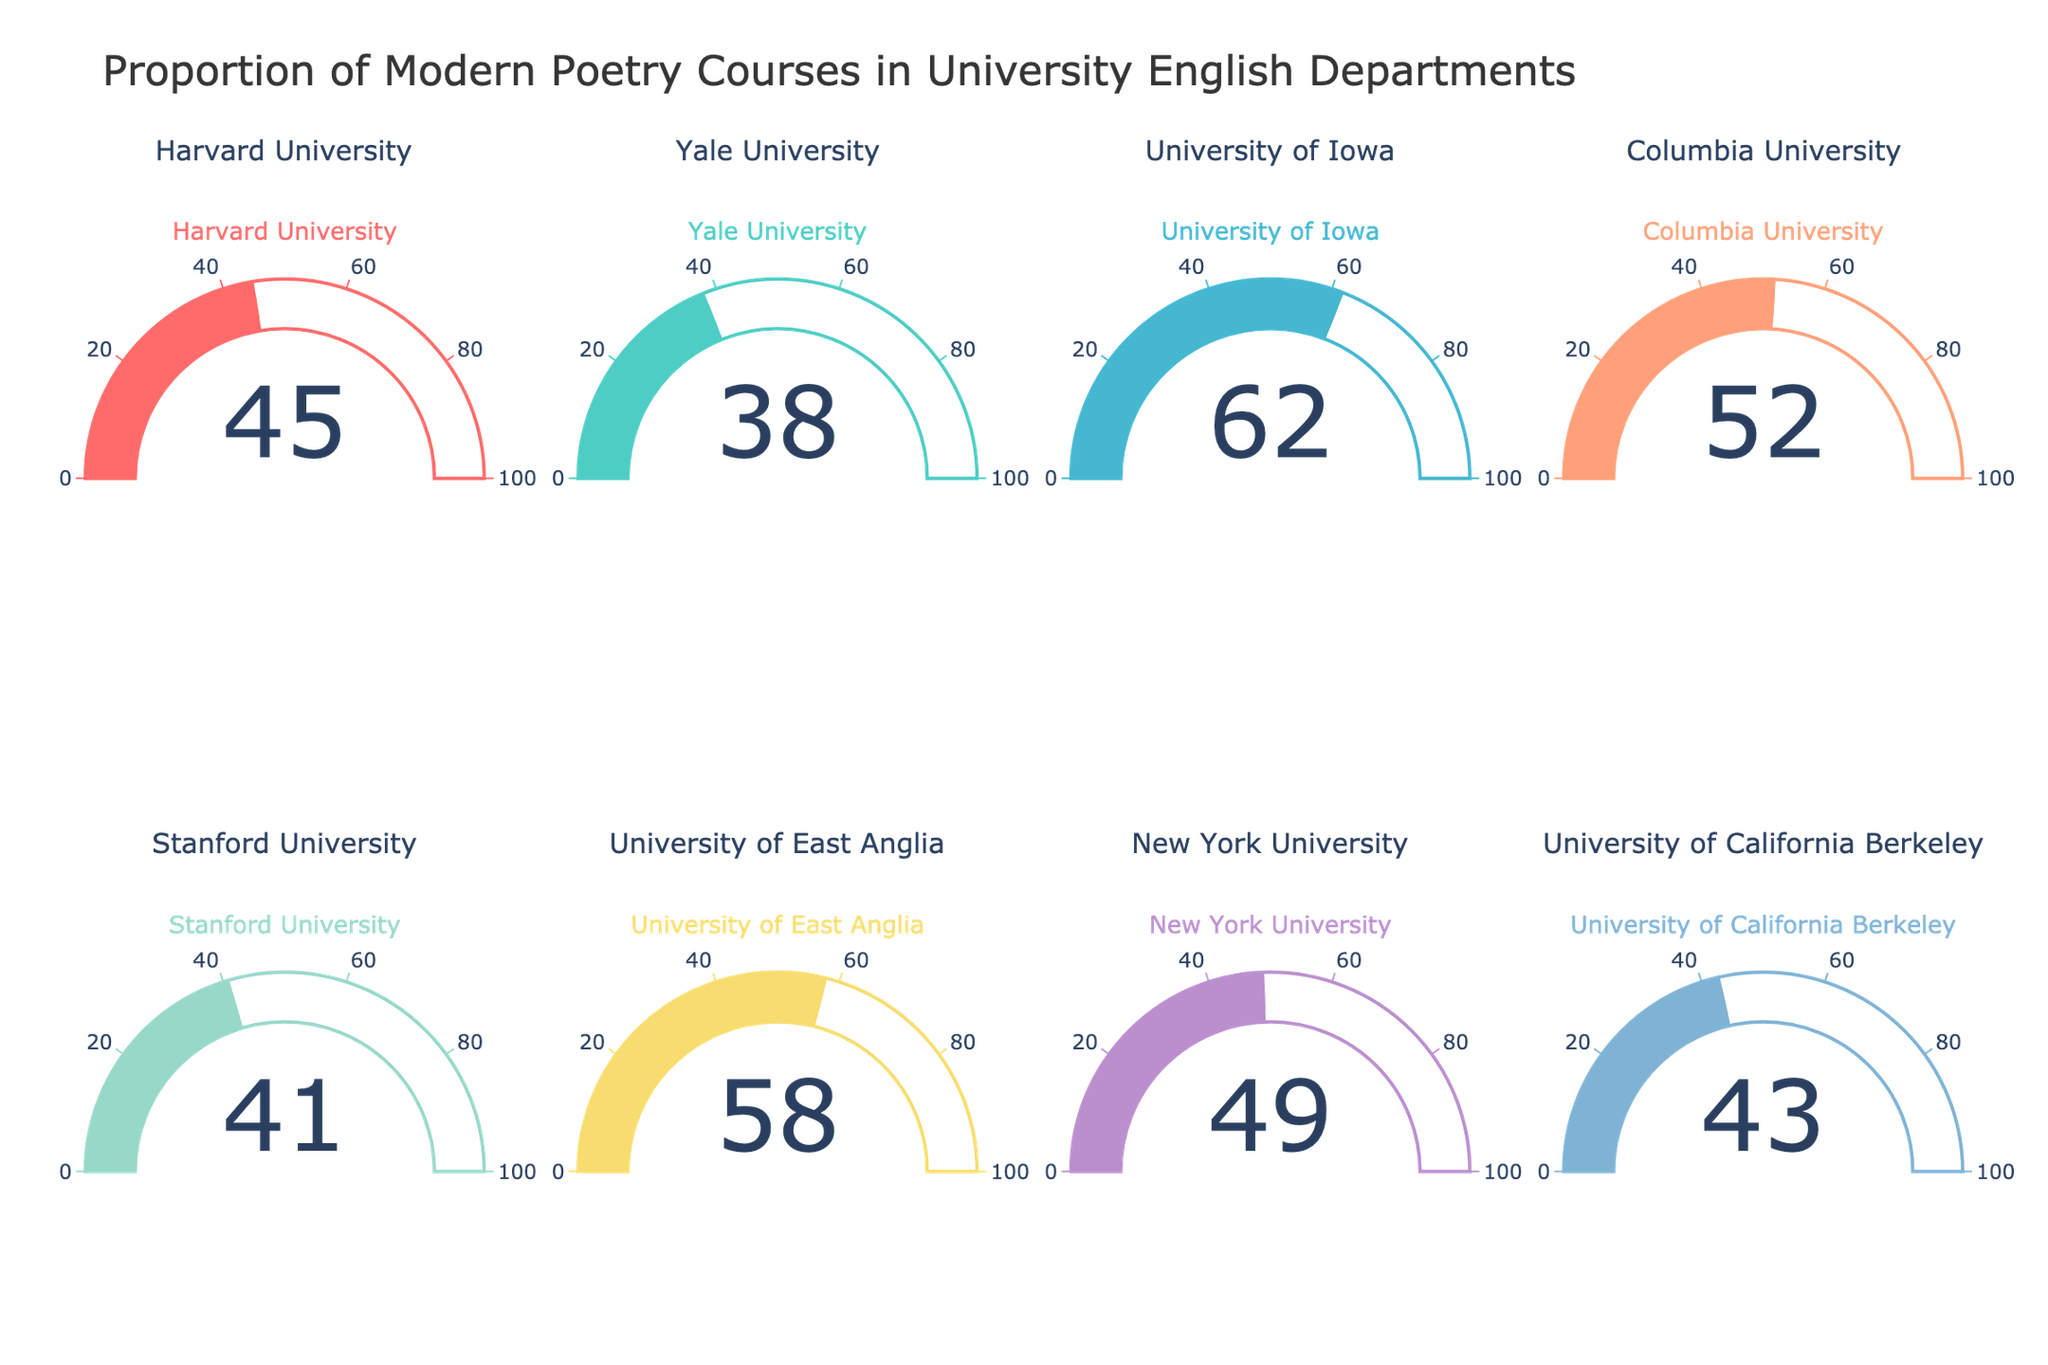what is the highest percentage of modern poetry courses offered? By examining the gauge charts, find the maximum value shown.
Answer: 62% Which university offers the lowest percentage of modern poetry courses? Look at all the gauge charts and identify the university with the smallest number.
Answer: Yale University What's the average percentage of modern poetry courses across all universities? Sum the percentages and divide by the number of universities: (45+38+62+52+41+58+49+43) / 8 = 388/8
Answer: 48.5% Compare the proportion of modern poetry courses at the Ivy League universities (Harvard, Yale, Columbia) to the non-Ivy League universities. Which group has a higher average? Calculate the average for Ivy League: (45+38+52)/3 = 135/3 and non-Ivy League: (62+41+58+49+43)/5 = 253/5. Compare the two averages.
Answer: Non-Ivy League How many universities have a percentage of modern poetry courses offered more than 50%? Count the number of universities where the gauge chart indicates a value greater than 50.
Answer: 3 Which university offers the closest percentage of modern poetry courses to the average percentage? Calculate the average percentage (48.5%). Compare the percentages of all universities to see which is closest to this value.
Answer: New York University Which two universities have the smallest difference in percentage of modern poetry courses offered? Identify pairs of universities and compute the differences, find the pair with the smallest difference:
Answer: Stanford and University of California Berkeley What is the median percentage of modern poetry courses offered across the universities? Order the percentages and find the middle value(s). For 8 data points: (41, 43, 45, 49, 52, 58, 62), it's the average of the 4th and 5th values: (49+52)/2.
Answer: 48 How does the proportion of modern poetry courses offered by Stanford compare to Columbia? Find the percentages for Stanford (41%) and Columbia (52%). Compare these values.
Answer: Columbia is higher 